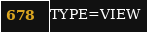Convert code to text. <code><loc_0><loc_0><loc_500><loc_500><_VisualBasic_>TYPE=VIEW</code> 